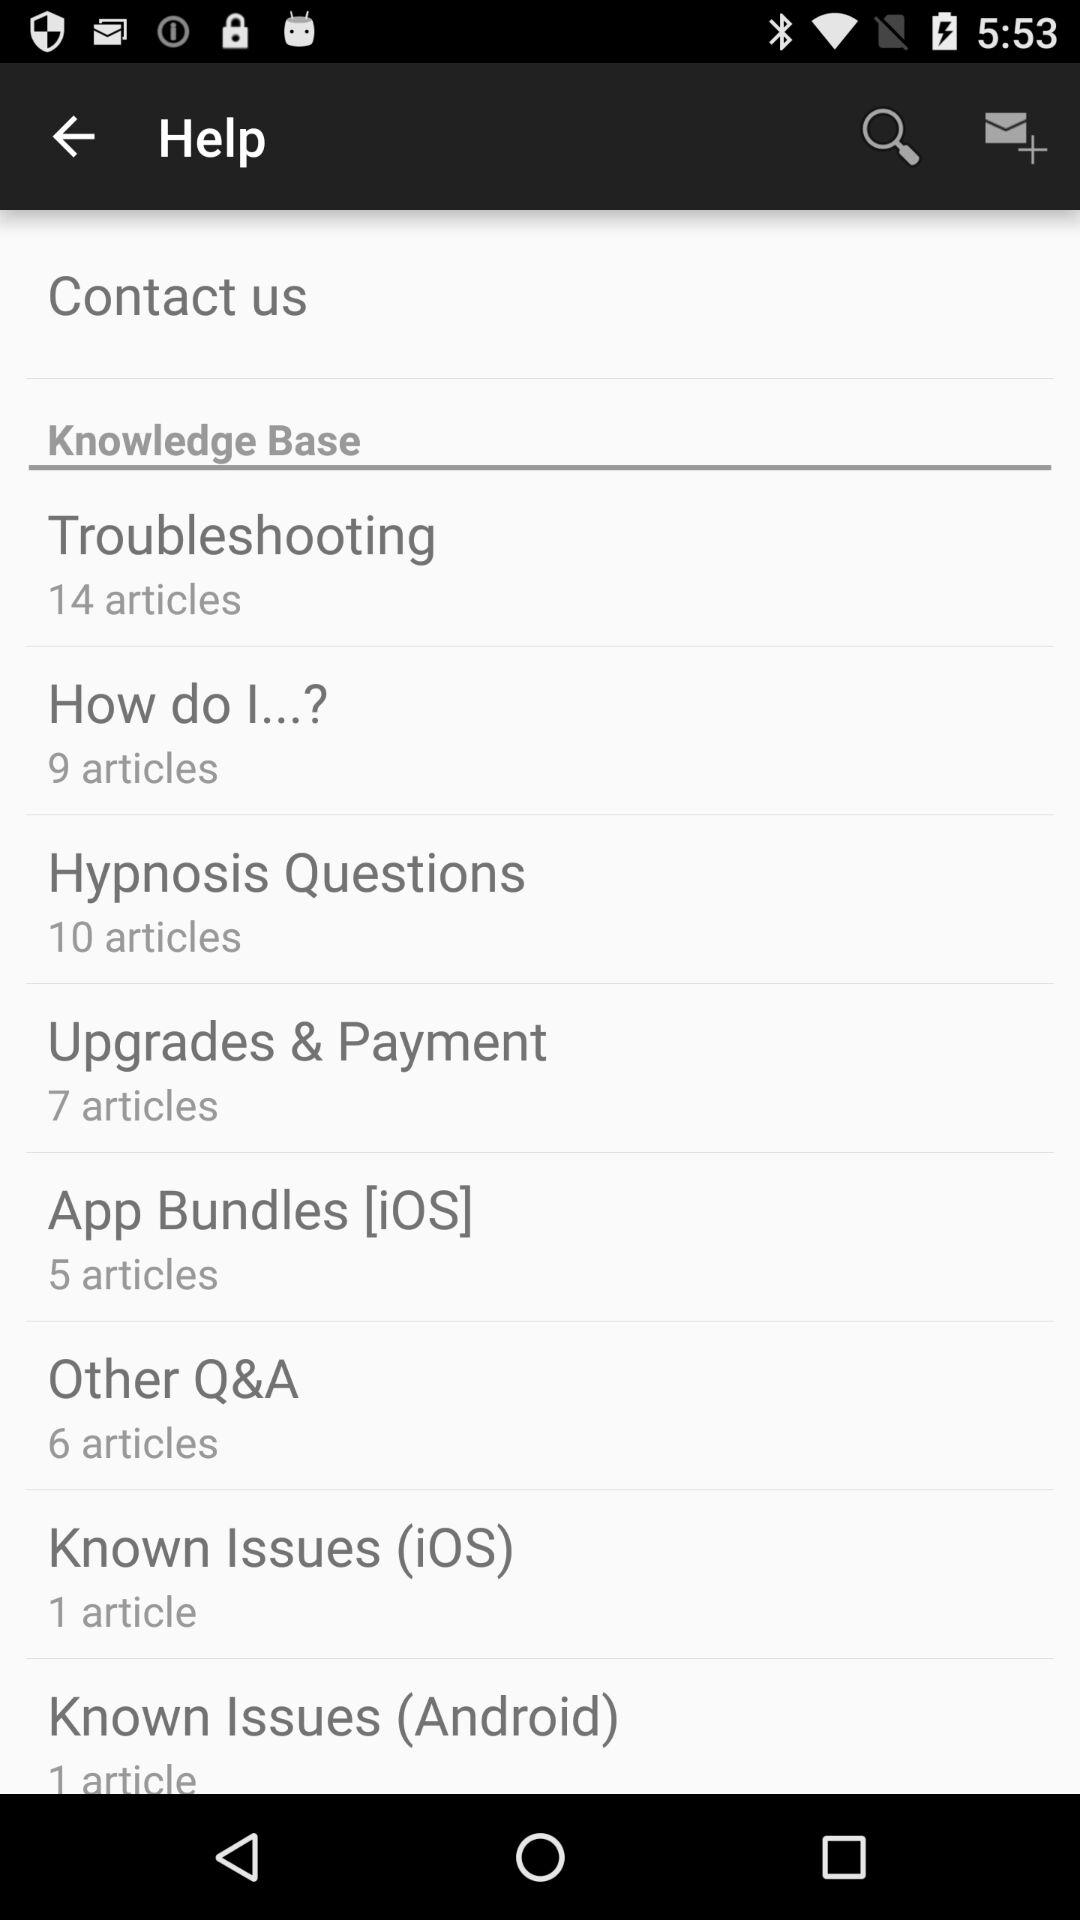How many articles are there about troubleshooting?
Answer the question using a single word or phrase. 14 